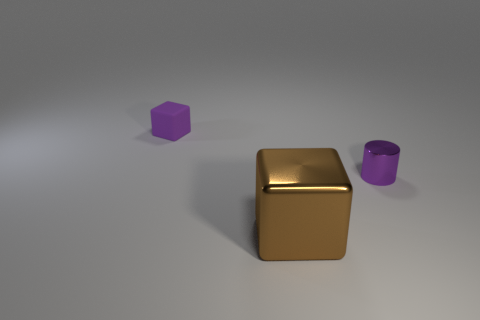Add 3 purple objects. How many objects exist? 6 Subtract all cubes. How many objects are left? 1 Add 3 tiny purple metal objects. How many tiny purple metal objects are left? 4 Add 1 purple matte cubes. How many purple matte cubes exist? 2 Subtract 0 yellow blocks. How many objects are left? 3 Subtract all red cubes. Subtract all red balls. How many cubes are left? 2 Subtract all big cubes. Subtract all small objects. How many objects are left? 0 